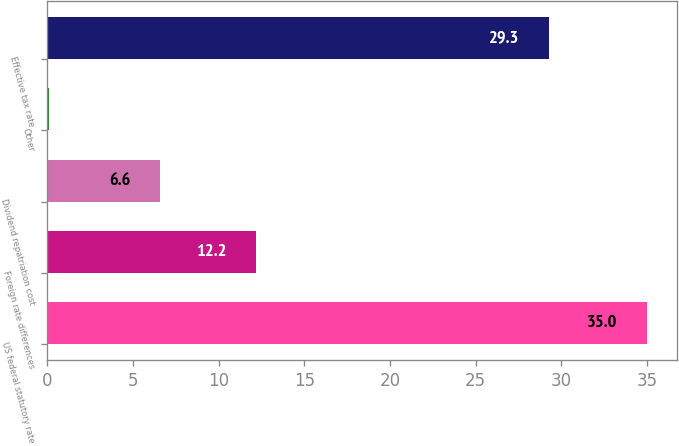Convert chart to OTSL. <chart><loc_0><loc_0><loc_500><loc_500><bar_chart><fcel>US federal statutory rate<fcel>Foreign rate differences<fcel>Dividend repatriation cost<fcel>Other<fcel>Effective tax rate<nl><fcel>35<fcel>12.2<fcel>6.6<fcel>0.1<fcel>29.3<nl></chart> 